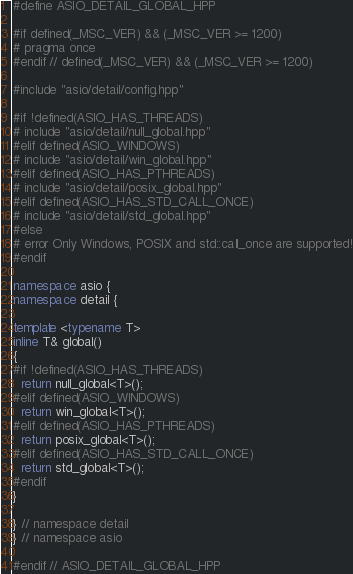Convert code to text. <code><loc_0><loc_0><loc_500><loc_500><_C++_>#define ASIO_DETAIL_GLOBAL_HPP

#if defined(_MSC_VER) && (_MSC_VER >= 1200)
# pragma once
#endif // defined(_MSC_VER) && (_MSC_VER >= 1200)

#include "asio/detail/config.hpp"

#if !defined(ASIO_HAS_THREADS)
# include "asio/detail/null_global.hpp"
#elif defined(ASIO_WINDOWS)
# include "asio/detail/win_global.hpp"
#elif defined(ASIO_HAS_PTHREADS)
# include "asio/detail/posix_global.hpp"
#elif defined(ASIO_HAS_STD_CALL_ONCE)
# include "asio/detail/std_global.hpp"
#else
# error Only Windows, POSIX and std::call_once are supported!
#endif

namespace asio {
namespace detail {

template <typename T>
inline T& global()
{
#if !defined(ASIO_HAS_THREADS)
  return null_global<T>();
#elif defined(ASIO_WINDOWS)
  return win_global<T>();
#elif defined(ASIO_HAS_PTHREADS)
  return posix_global<T>();
#elif defined(ASIO_HAS_STD_CALL_ONCE)
  return std_global<T>();
#endif
}

} // namespace detail
} // namespace asio

#endif // ASIO_DETAIL_GLOBAL_HPP
</code> 